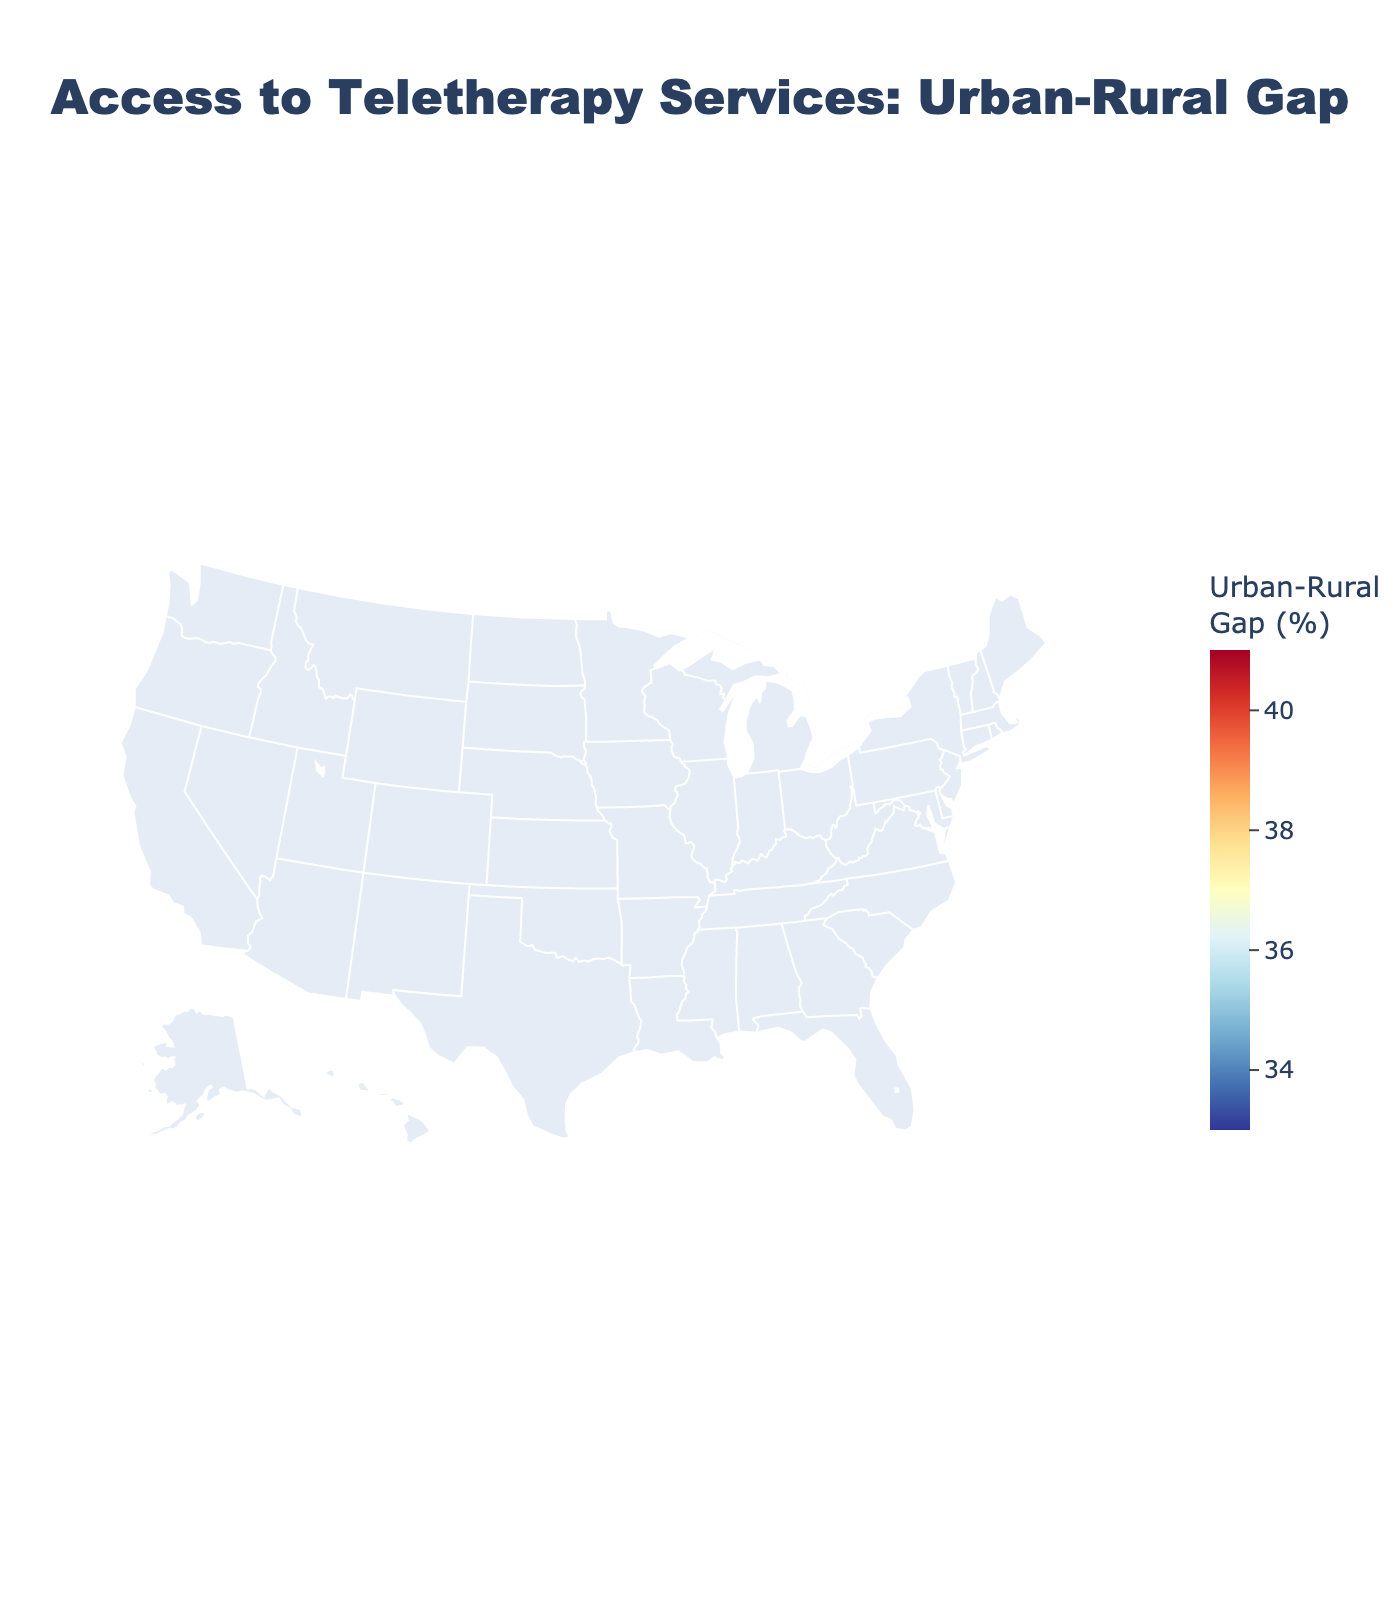What is the title of the plot? The title is located at the top of the plot. It is usually written in larger and bold text for emphasis.
Answer: Access to Teletherapy Services: Urban-Rural Gap Which state shows the highest urban-rural gap in teletherapy access? To find the state with the highest gap, look for the state with the darkest shade on the color scale, as the plot uses a color gradient to represent differences.
Answer: New York What is the urban access percentage for Vermont? Hover over Vermont on the map to reveal a tooltip that shows both urban and rural access percentages.
Answer: 88% What is the difference between rural and urban access in Alaska? Hover over Alaska to find the rural access percentage (29%) and urban access percentage (70%). Subtract rural access from urban access to get the difference.
Answer: 41% Which state has the closest urban-rural gap to the national average? To answer this, calculate the average of all "Rural-Urban Difference" values, then look for a state whose difference is closest to this average.
Answer: California In which states is the urban access to teletherapy below 75%? Look for states with "Urban Access (%)" values less than 75%. This information can be found by hovering over relevant states.
Answer: Wyoming, Alaska, South Dakota Compare the average rural access percentage between states with an urban-rural gap above 40% and those with a gap below 40%. What do you find? First, segregate the states into two groups based on whether their gap is above or below 40%. Calculate the average rural access for each group and compare.
Answer: Group above 40% has lower average rural access Is there any state where rural access is over 50%? Hover over all states to check their rural access percentages. Identify states with rural access percentages greater than 50%.
Answer: Vermont What is the average urban-rural gap for the states listed? Sum all the "Rural-Urban Difference" values and divide by the number of states to get the average gap.
Answer: 41% Which state shows a smaller gap, Georgia or Iowa? Hover over both states to find their "Rural-Urban Difference" values. Compare these values to see which is smaller.
Answer: Iowa 